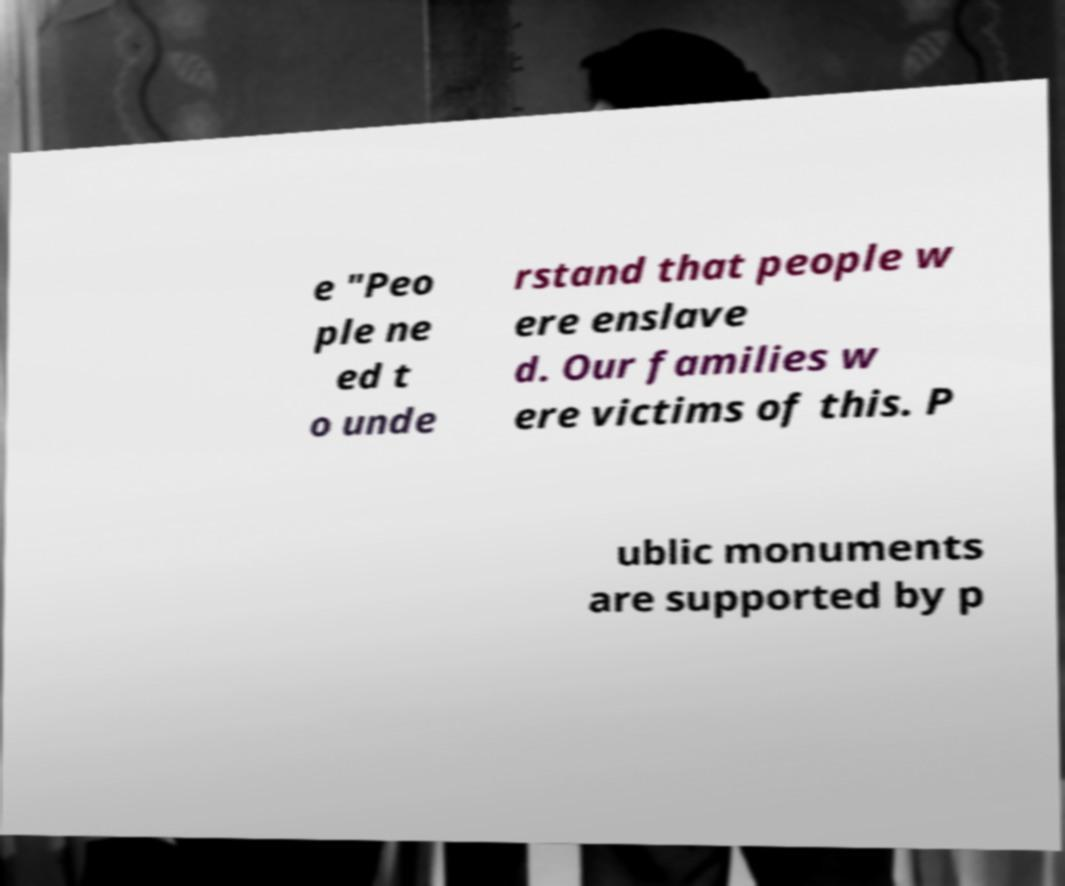There's text embedded in this image that I need extracted. Can you transcribe it verbatim? e "Peo ple ne ed t o unde rstand that people w ere enslave d. Our families w ere victims of this. P ublic monuments are supported by p 